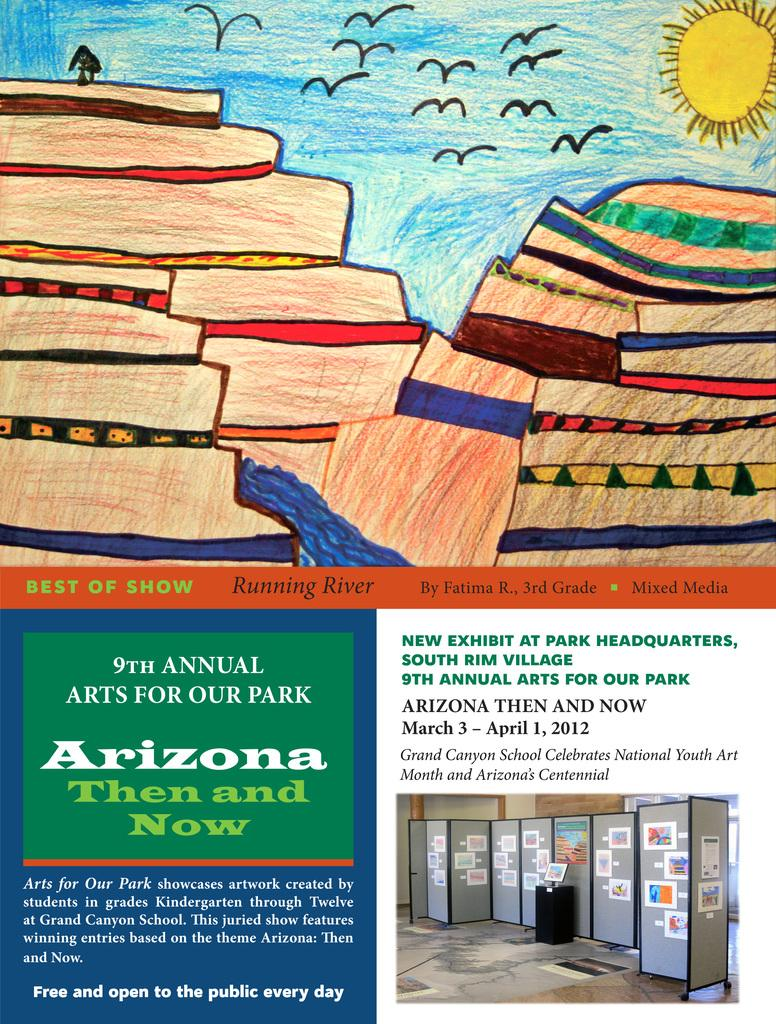<image>
Give a short and clear explanation of the subsequent image. A poster for an art show in Arizona called Then and Now. 